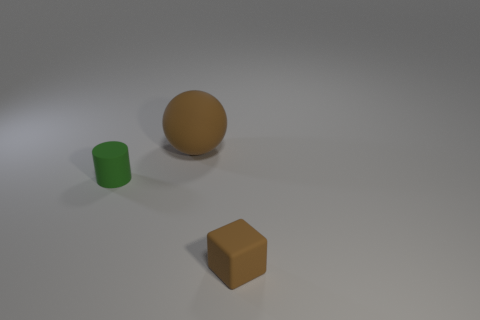Add 1 big shiny cubes. How many objects exist? 4 Subtract 1 blocks. How many blocks are left? 0 Subtract all blocks. How many objects are left? 2 Subtract all matte things. Subtract all big blue metal balls. How many objects are left? 0 Add 1 tiny brown matte blocks. How many tiny brown matte blocks are left? 2 Add 1 tiny brown rubber cubes. How many tiny brown rubber cubes exist? 2 Subtract 0 gray blocks. How many objects are left? 3 Subtract all blue cylinders. Subtract all green balls. How many cylinders are left? 1 